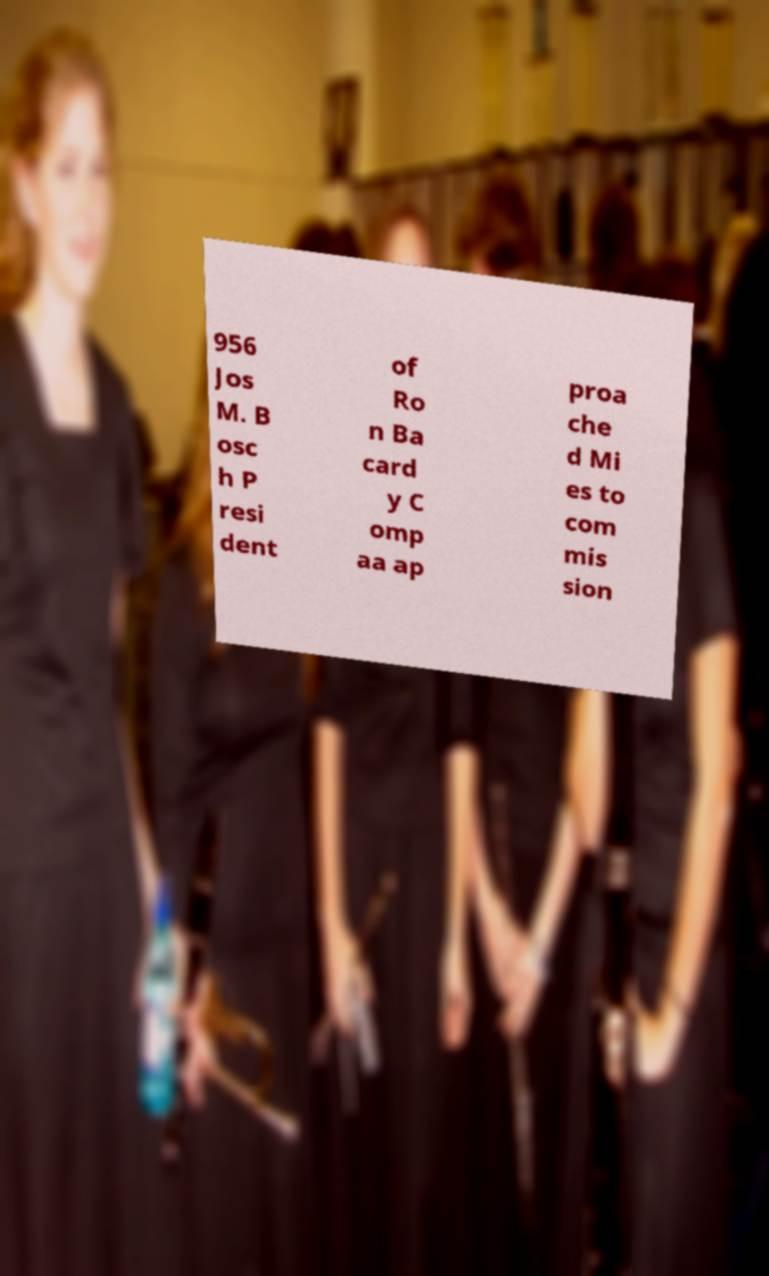Can you accurately transcribe the text from the provided image for me? 956 Jos M. B osc h P resi dent of Ro n Ba card y C omp aa ap proa che d Mi es to com mis sion 